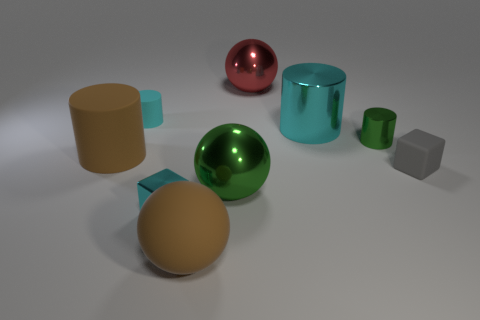Subtract all brown rubber spheres. How many spheres are left? 2 Subtract 1 cylinders. How many cylinders are left? 3 Subtract all brown cylinders. How many cylinders are left? 3 Subtract all cylinders. How many objects are left? 5 Subtract all blue cylinders. Subtract all yellow blocks. How many cylinders are left? 4 Add 7 small gray objects. How many small gray objects exist? 8 Subtract 0 purple cylinders. How many objects are left? 9 Subtract all tiny gray metal cubes. Subtract all tiny cyan rubber cylinders. How many objects are left? 8 Add 3 tiny matte cylinders. How many tiny matte cylinders are left? 4 